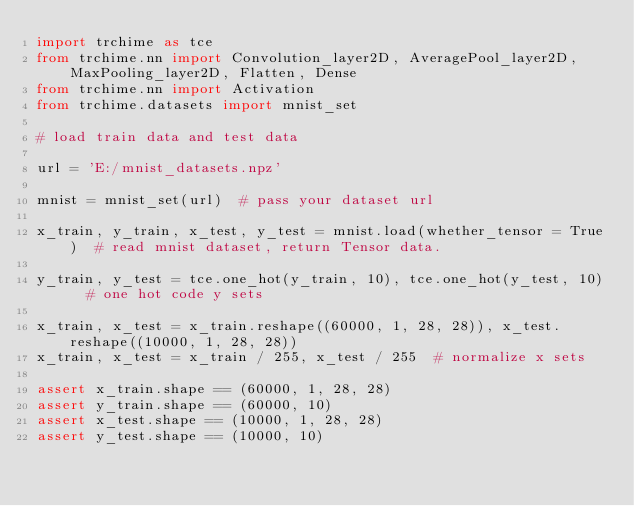<code> <loc_0><loc_0><loc_500><loc_500><_Python_>import trchime as tce
from trchime.nn import Convolution_layer2D, AveragePool_layer2D, MaxPooling_layer2D, Flatten, Dense
from trchime.nn import Activation
from trchime.datasets import mnist_set

# load train data and test data

url = 'E:/mnist_datasets.npz'

mnist = mnist_set(url)  # pass your dataset url

x_train, y_train, x_test, y_test = mnist.load(whether_tensor = True)  # read mnist dataset, return Tensor data.

y_train, y_test = tce.one_hot(y_train, 10), tce.one_hot(y_test, 10)  # one hot code y sets

x_train, x_test = x_train.reshape((60000, 1, 28, 28)), x_test.reshape((10000, 1, 28, 28))
x_train, x_test = x_train / 255, x_test / 255  # normalize x sets

assert x_train.shape == (60000, 1, 28, 28)
assert y_train.shape == (60000, 10)
assert x_test.shape == (10000, 1, 28, 28)
assert y_test.shape == (10000, 10)

</code> 